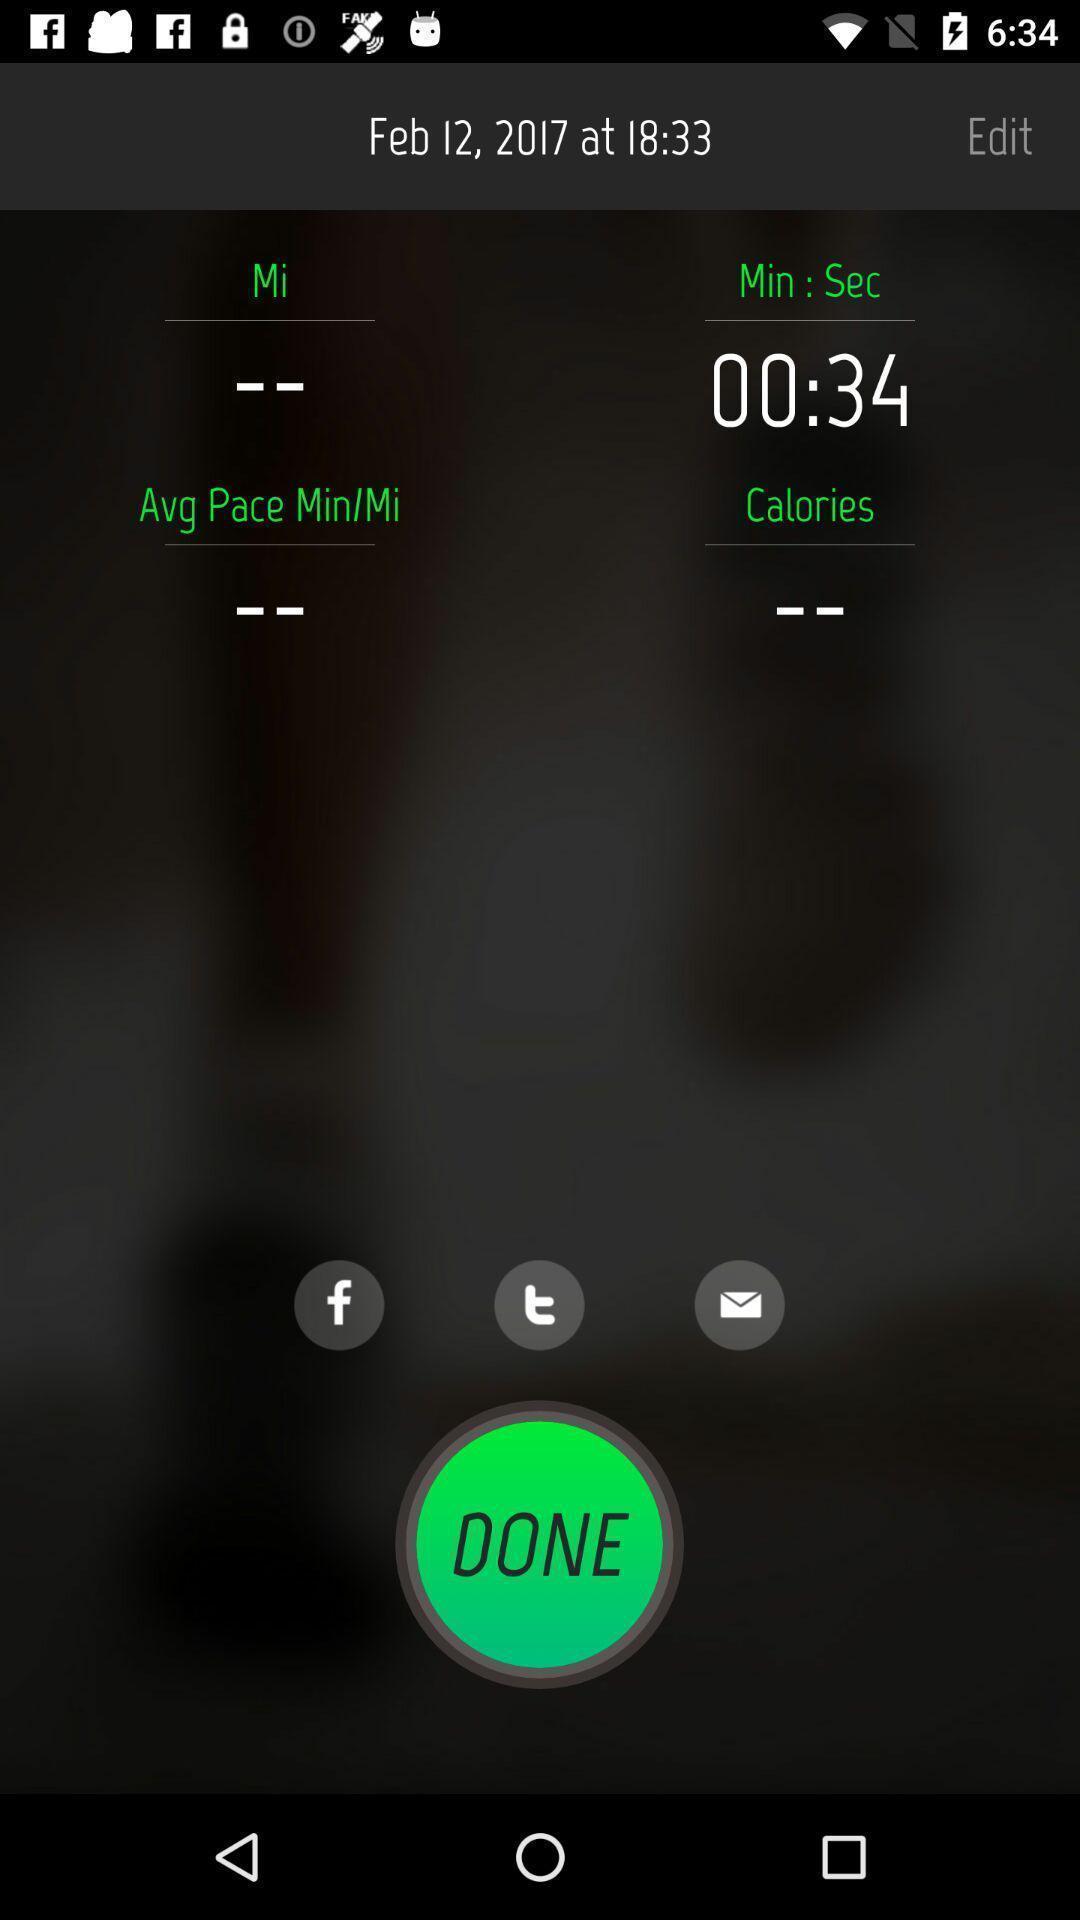Explain the elements present in this screenshot. Tracked listings in a fitness tracker app. 